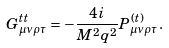Convert formula to latex. <formula><loc_0><loc_0><loc_500><loc_500>G ^ { t t } _ { \mu \nu \rho \tau } = - \frac { 4 i } { M ^ { 2 } q ^ { 2 } } P ^ { ( t ) } _ { \mu \nu \rho \tau } .</formula> 